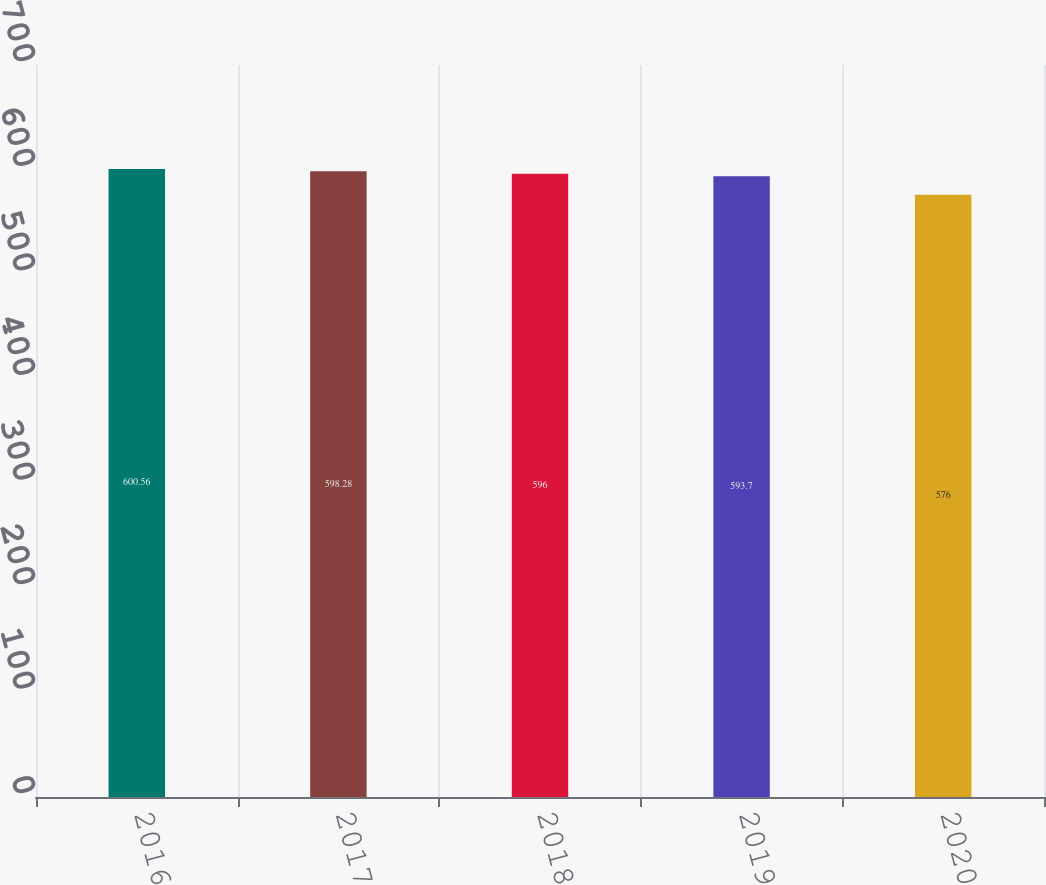Convert chart to OTSL. <chart><loc_0><loc_0><loc_500><loc_500><bar_chart><fcel>2016<fcel>2017<fcel>2018<fcel>2019<fcel>2020<nl><fcel>600.56<fcel>598.28<fcel>596<fcel>593.7<fcel>576<nl></chart> 